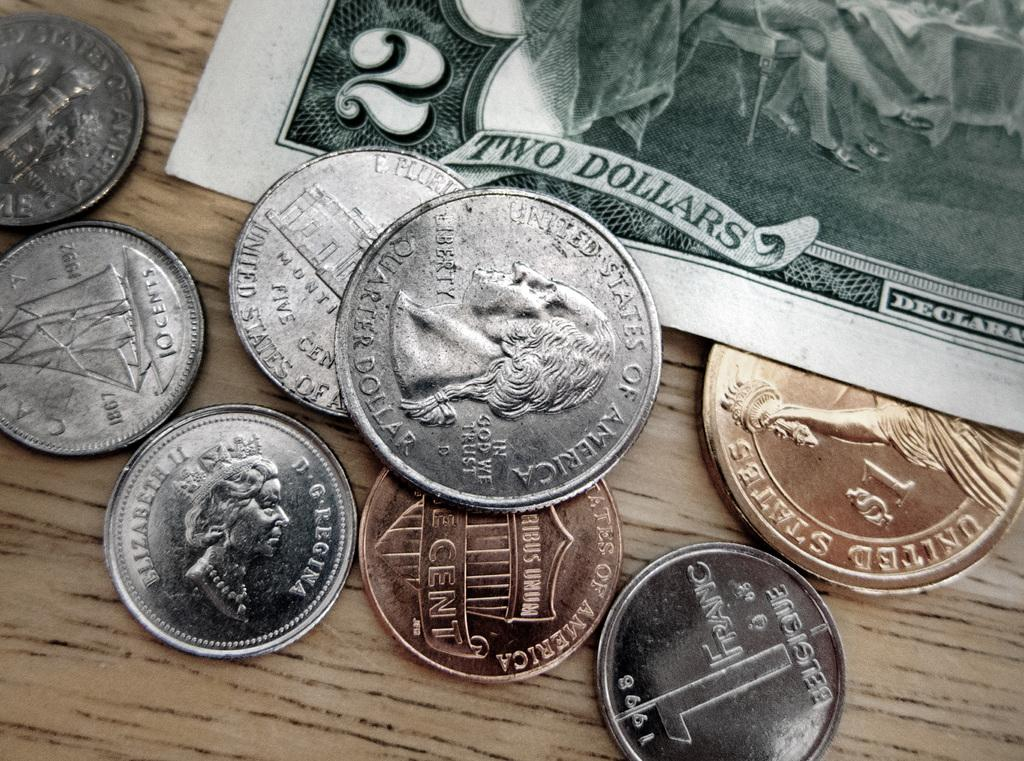<image>
Describe the image concisely. A 2 dollar US bill and some American and Canadian coins rest together on a table. 